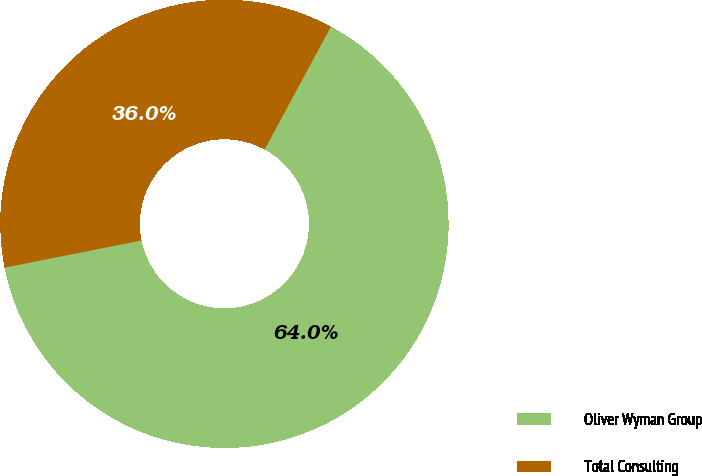Convert chart to OTSL. <chart><loc_0><loc_0><loc_500><loc_500><pie_chart><fcel>Oliver Wyman Group<fcel>Total Consulting<nl><fcel>64.0%<fcel>36.0%<nl></chart> 